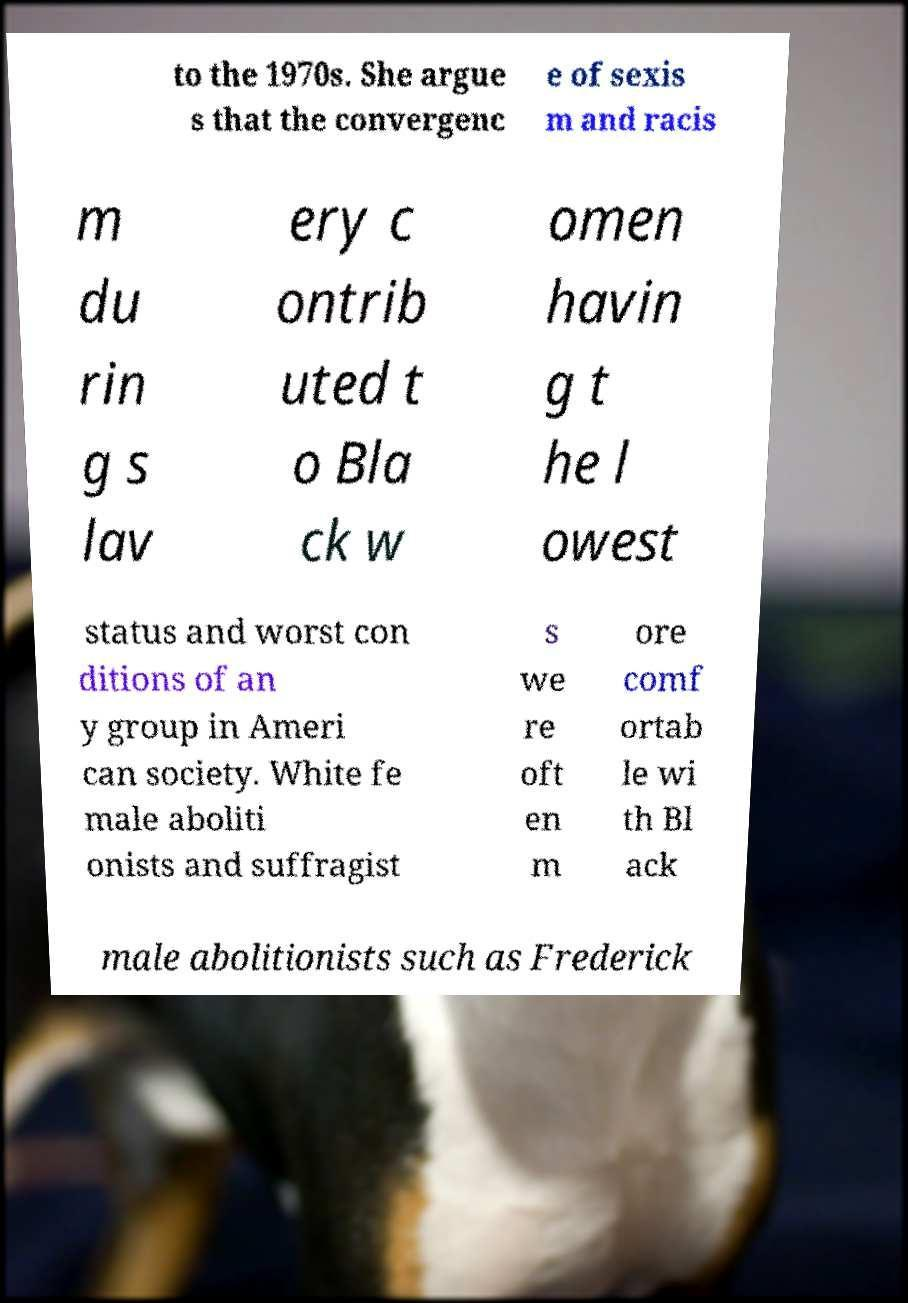Can you accurately transcribe the text from the provided image for me? to the 1970s. She argue s that the convergenc e of sexis m and racis m du rin g s lav ery c ontrib uted t o Bla ck w omen havin g t he l owest status and worst con ditions of an y group in Ameri can society. White fe male aboliti onists and suffragist s we re oft en m ore comf ortab le wi th Bl ack male abolitionists such as Frederick 